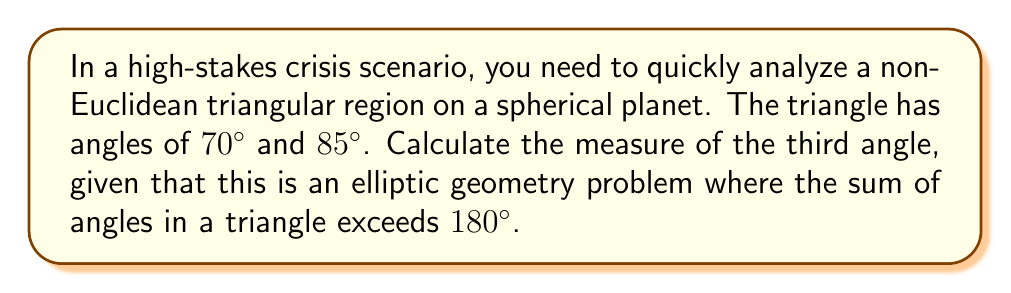Can you answer this question? Let's approach this step-by-step:

1) In elliptic geometry, which is the geometry on the surface of a sphere, the sum of angles in a triangle is always greater than $180°$.

2) The formula for the sum of angles in a triangle on a sphere is:

   $$ \alpha + \beta + \gamma = 180° + \frac{A}{R^2} $$

   Where $\alpha$, $\beta$, and $\gamma$ are the angles of the triangle, $A$ is the area of the triangle, and $R$ is the radius of the sphere.

3) The term $\frac{A}{R^2}$ is called the spherical excess and is always positive.

4) Let's call our unknown angle $x$. We can set up an equation:

   $$ 70° + 85° + x = 180° + \text{spherical excess} $$

5) Simplify the left side:

   $$ 155° + x = 180° + \text{spherical excess} $$

6) Subtract $155°$ from both sides:

   $$ x = 25° + \text{spherical excess} $$

7) Since the spherical excess is always positive, we know that $x$ must be greater than $25°$.

8) Therefore, the third angle is $25°$ plus some positive value.

This approach allows for quick analysis in a crisis situation, providing a lower bound for the angle without needing to know the specific area or radius of the spherical planet.
Answer: $x > 25°$ 